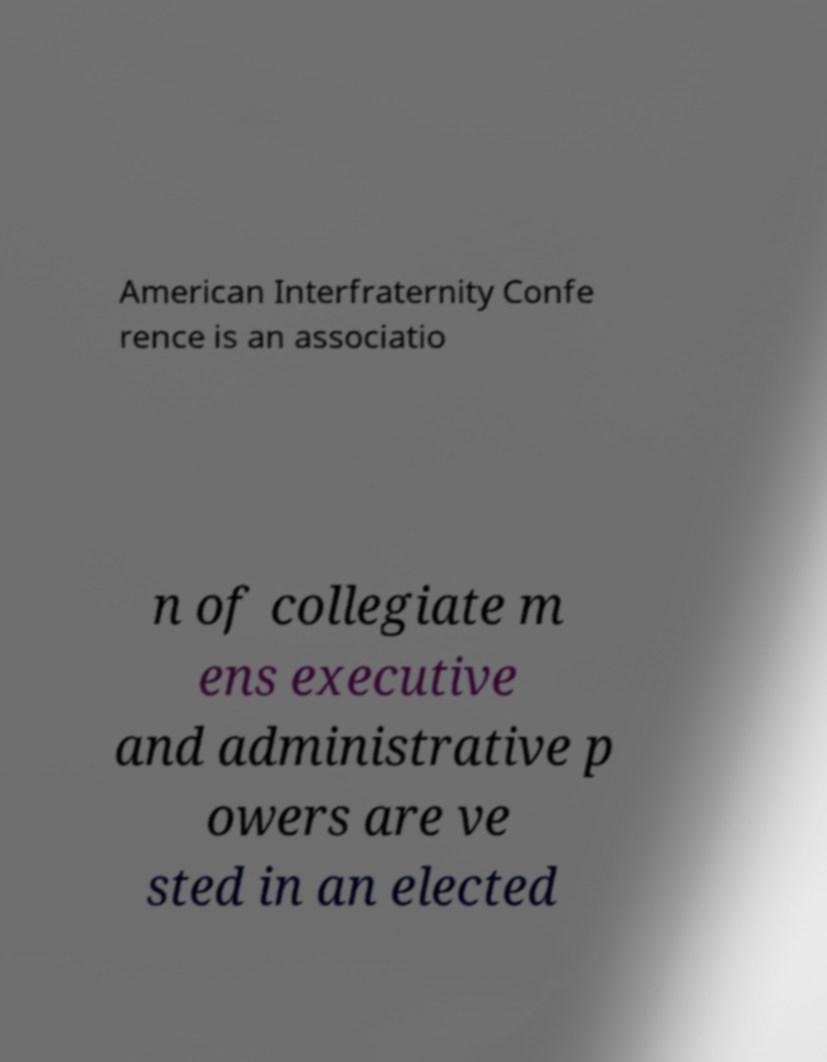Could you extract and type out the text from this image? American Interfraternity Confe rence is an associatio n of collegiate m ens executive and administrative p owers are ve sted in an elected 